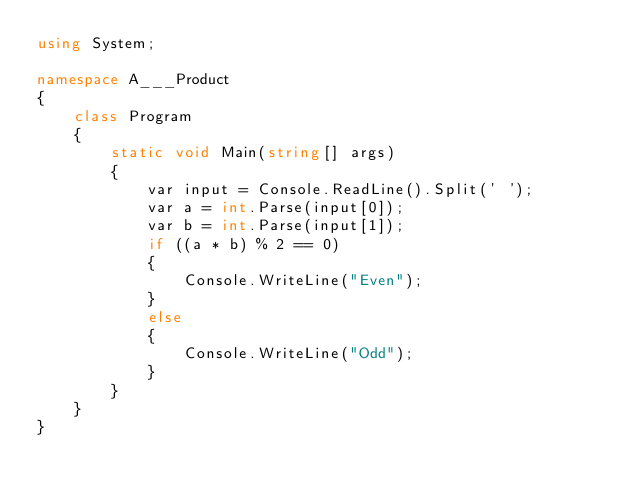Convert code to text. <code><loc_0><loc_0><loc_500><loc_500><_C#_>using System;

namespace A___Product
{
    class Program
    {
        static void Main(string[] args)
        {
            var input = Console.ReadLine().Split(' ');
            var a = int.Parse(input[0]);
            var b = int.Parse(input[1]);
            if ((a * b) % 2 == 0)
            {
                Console.WriteLine("Even");
            }
            else
            {
                Console.WriteLine("Odd");
            }
        }
    }
}</code> 